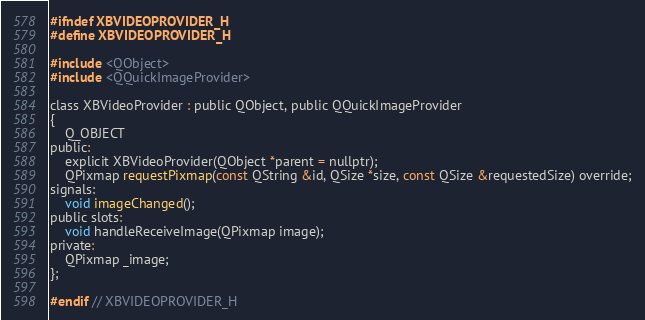Convert code to text. <code><loc_0><loc_0><loc_500><loc_500><_C_>#ifndef XBVIDEOPROVIDER_H
#define XBVIDEOPROVIDER_H

#include <QObject>
#include <QQuickImageProvider>

class XBVideoProvider : public QObject, public QQuickImageProvider
{
    Q_OBJECT
public:
    explicit XBVideoProvider(QObject *parent = nullptr);
    QPixmap requestPixmap(const QString &id, QSize *size, const QSize &requestedSize) override;
signals:
    void imageChanged();
public slots:
    void handleReceiveImage(QPixmap image);
private:
    QPixmap _image;
};

#endif // XBVIDEOPROVIDER_H
</code> 